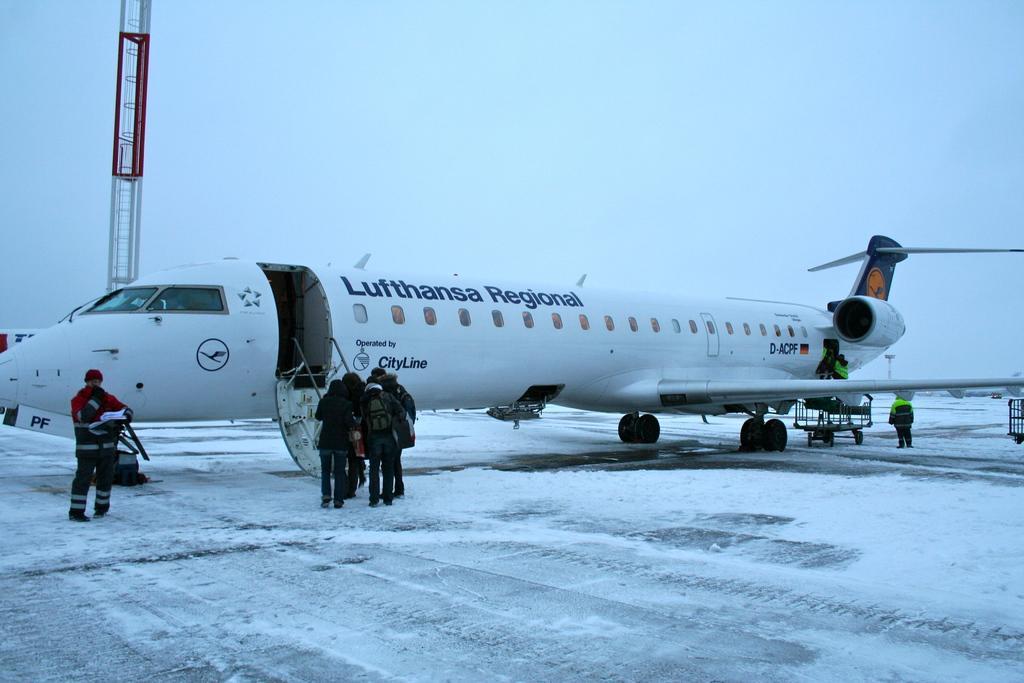How would you summarize this image in a sentence or two? In this image there are some persons standing on the left side of this image and there is one person standing on the right side of this image and there is a plane in middle of this image. There is a ground in bottom of this image. There is a sky on the top of this image. 